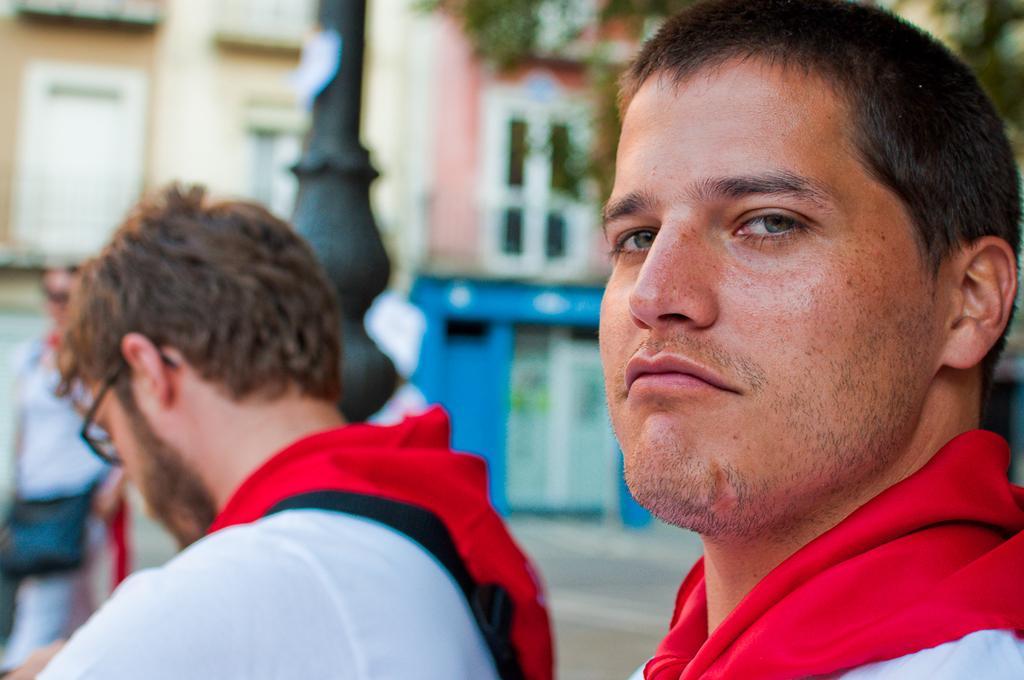How would you summarize this image in a sentence or two? Here we can see two men. In the background the image is blur but we can see a person,bag,windows,wall and a tree. 